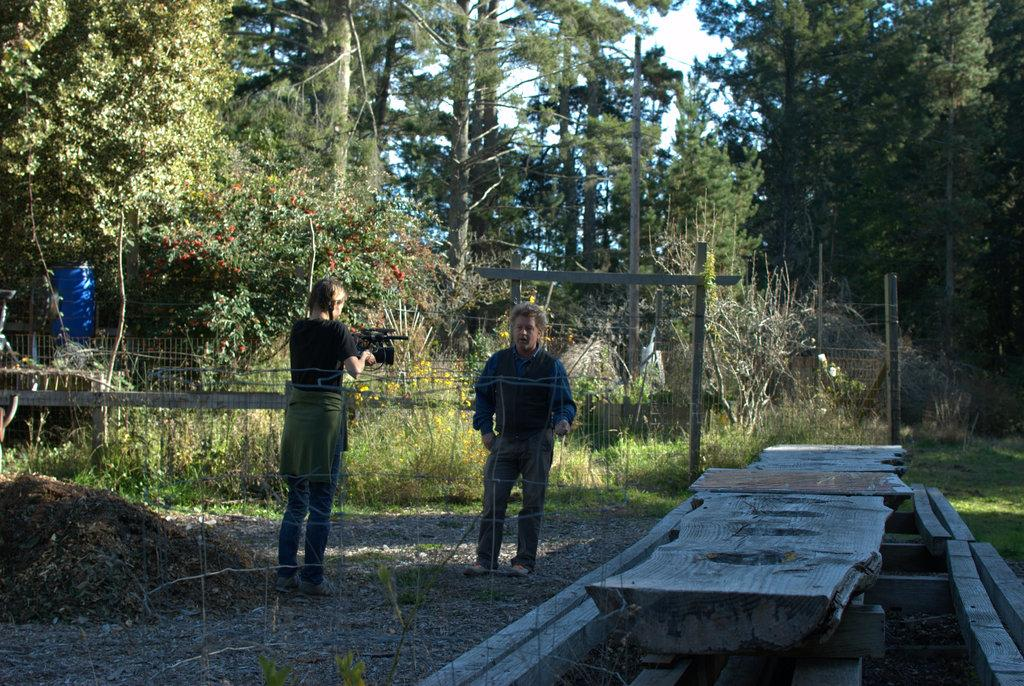How many people are in the image? There are people in the image, but the exact number is not specified. What can be seen in the image besides the people? There are poles, a mesh, the ground, grass, plants, flowers, trees, and a few objects visible in the image. What is the background of the image? The sky is visible in the background of the image. What type of vegetation is present in the image? There are plants, flowers, and trees in the image. What is the tendency of the screws to fall off the poles in the image? There are no screws present in the image, so it is not possible to determine their tendency to fall off the poles. How many oranges are visible in the image? There are no oranges present in the image. 